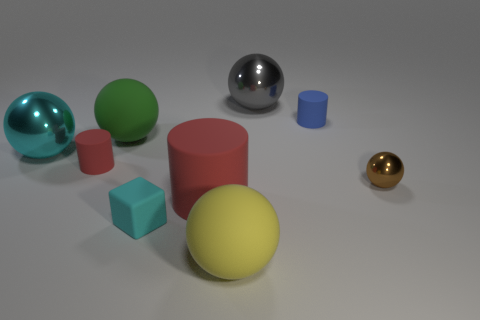There is another cylinder that is the same color as the large cylinder; what is its size?
Give a very brief answer. Small. What size is the yellow thing that is made of the same material as the large green ball?
Offer a terse response. Large. Is the material of the gray thing the same as the tiny blue thing?
Offer a terse response. No. What is the color of the matte ball behind the red rubber cylinder in front of the tiny sphere that is behind the large red rubber object?
Your answer should be very brief. Green. What is the shape of the small blue matte thing?
Ensure brevity in your answer.  Cylinder. Does the matte block have the same color as the tiny matte cylinder on the right side of the big yellow rubber thing?
Your answer should be compact. No. Is the number of big yellow matte things that are right of the small blue matte object the same as the number of large blue matte spheres?
Offer a very short reply. Yes. How many cyan matte blocks are the same size as the yellow object?
Offer a terse response. 0. There is a metal thing that is the same color as the tiny block; what is its shape?
Your response must be concise. Sphere. Are any tiny brown rubber cylinders visible?
Keep it short and to the point. No. 